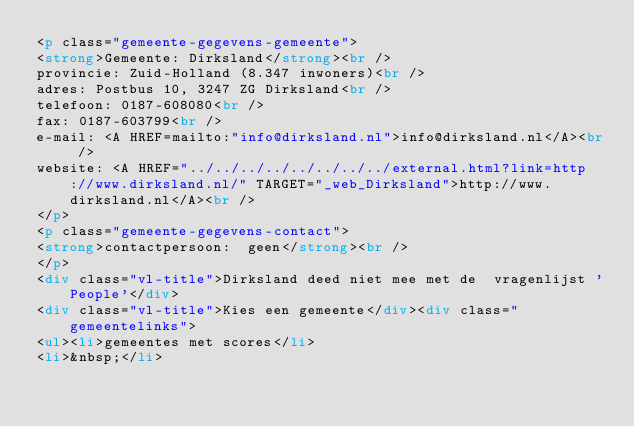<code> <loc_0><loc_0><loc_500><loc_500><_HTML_><p class="gemeente-gegevens-gemeente">
<strong>Gemeente: Dirksland</strong><br />
provincie: Zuid-Holland (8.347 inwoners)<br />
adres: Postbus 10, 3247 ZG Dirksland<br />
telefoon: 0187-608080<br />
fax: 0187-603799<br />
e-mail: <A HREF=mailto:"info@dirksland.nl">info@dirksland.nl</A><br />
website: <A HREF="../../../../../../../../external.html?link=http://www.dirksland.nl/" TARGET="_web_Dirksland">http://www.dirksland.nl</A><br />
</p>
<p class="gemeente-gegevens-contact">
<strong>contactpersoon:  geen</strong><br />
</p>
<div class="vl-title">Dirksland deed niet mee met de  vragenlijst 'People'</div>
<div class="vl-title">Kies een gemeente</div><div class="gemeentelinks">
<ul><li>gemeentes met scores</li>
<li>&nbsp;</li></code> 